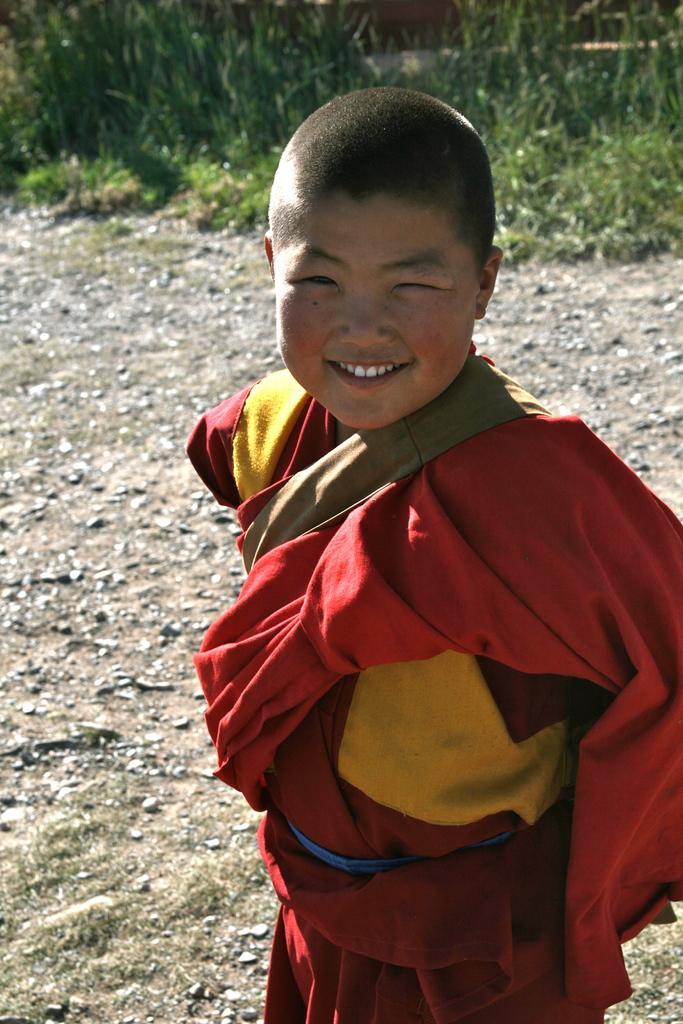In one or two sentences, can you explain what this image depicts? In the image we can see there is a kid standing and he is wearing red colour dress. Behind there are plants on the ground. 